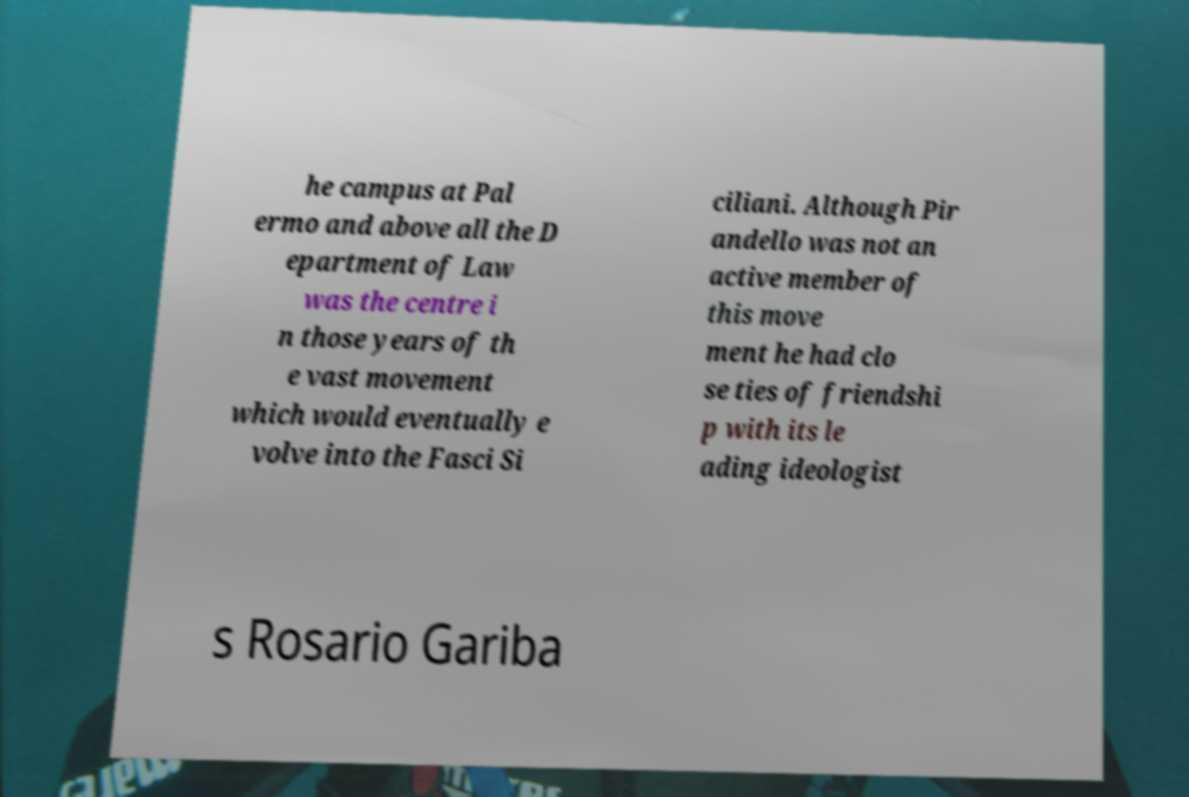Can you accurately transcribe the text from the provided image for me? he campus at Pal ermo and above all the D epartment of Law was the centre i n those years of th e vast movement which would eventually e volve into the Fasci Si ciliani. Although Pir andello was not an active member of this move ment he had clo se ties of friendshi p with its le ading ideologist s Rosario Gariba 